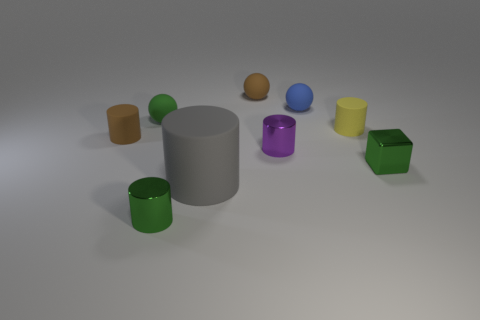Subtract all yellow cylinders. How many cylinders are left? 4 Subtract all green metallic cylinders. How many cylinders are left? 4 Subtract all cyan cylinders. Subtract all purple blocks. How many cylinders are left? 5 Add 1 small purple cylinders. How many objects exist? 10 Subtract all big green metallic objects. Subtract all green metallic blocks. How many objects are left? 8 Add 5 blue matte balls. How many blue matte balls are left? 6 Add 6 green metal cylinders. How many green metal cylinders exist? 7 Subtract 0 red cubes. How many objects are left? 9 Subtract all cylinders. How many objects are left? 4 